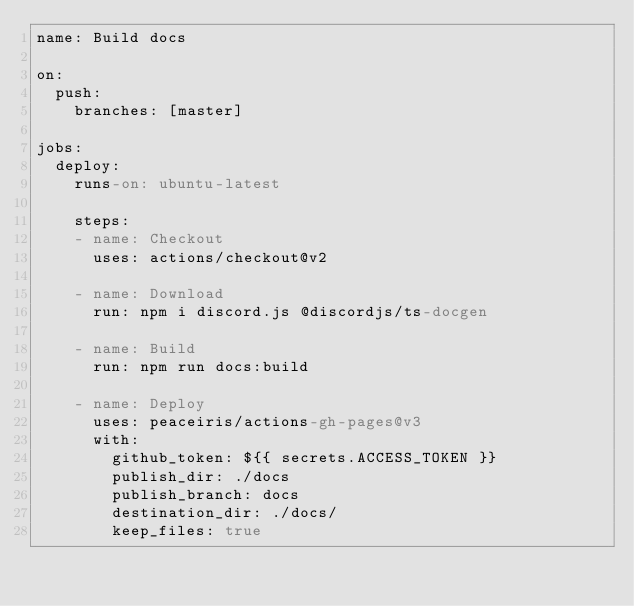Convert code to text. <code><loc_0><loc_0><loc_500><loc_500><_YAML_>name: Build docs

on:
  push:
    branches: [master]

jobs:
  deploy:
    runs-on: ubuntu-latest

    steps:
    - name: Checkout
      uses: actions/checkout@v2

    - name: Download
      run: npm i discord.js @discordjs/ts-docgen

    - name: Build
      run: npm run docs:build

    - name: Deploy
      uses: peaceiris/actions-gh-pages@v3
      with:
        github_token: ${{ secrets.ACCESS_TOKEN }}
        publish_dir: ./docs
        publish_branch: docs
        destination_dir: ./docs/
        keep_files: true
</code> 